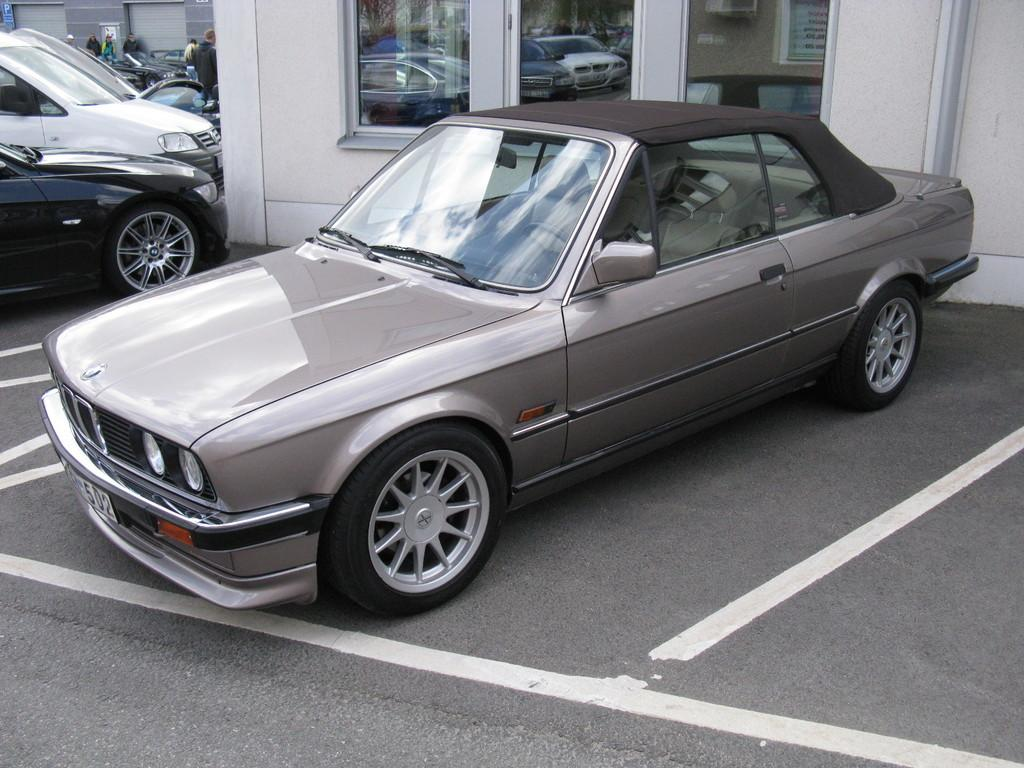What is the main subject in the center of the image? There is a car in the center of the image. Where is the car located? The car is on the road. What can be seen on the left side of the road? There are many cars and persons on the left side of the road. What is visible in the background of the image? There are windows and at least one building visible in the background. How much powder is needed to begin baking a cake in the image? There is no reference to baking or powder in the image; it features a car on the road with other cars and persons nearby. 